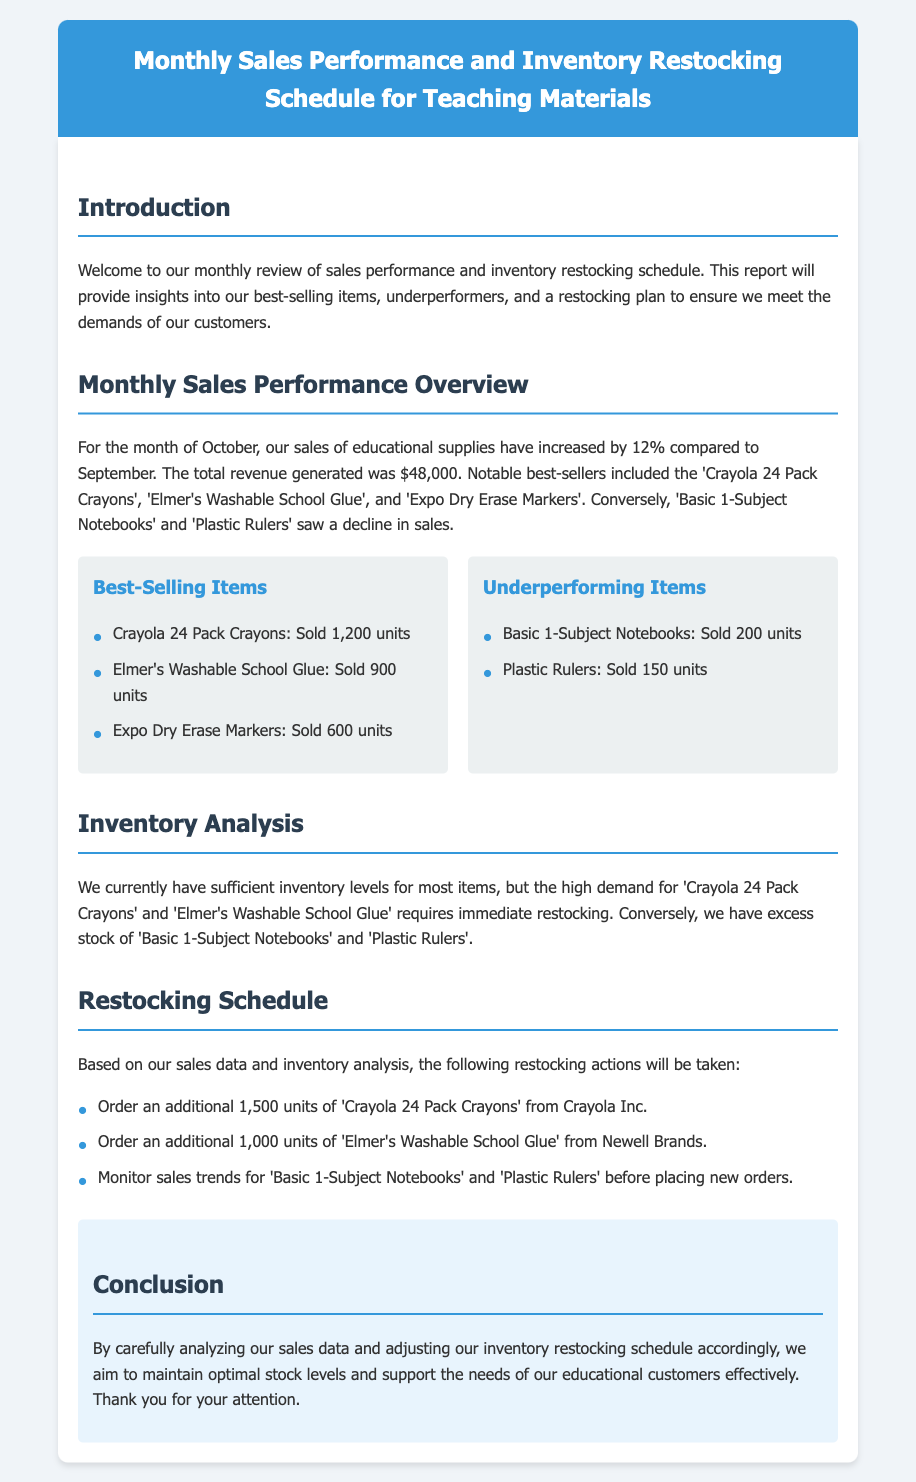What was the percentage increase in sales for October? The document states that sales increased by 12% compared to September.
Answer: 12% What is the total revenue generated in October? The document mentions the total revenue generated for the month of October was $48,000.
Answer: $48,000 How many units of 'Crayola 24 Pack Crayons' were sold? The document lists 1,200 units sold for 'Crayola 24 Pack Crayons'.
Answer: 1,200 units Which item saw a decline in sales? The document states that 'Basic 1-Subject Notebooks' and 'Plastic Rulers' saw a decline in sales.
Answer: Basic 1-Subject Notebooks What are the restocking quantities for 'Elmer's Washable School Glue'? The restocking action states to order an additional 1,000 units of 'Elmer's Washable School Glue'.
Answer: 1,000 units What is the conclusion's focus regarding stock levels? The conclusion emphasizes maintaining optimal stock levels based on sales data and inventory analysis.
Answer: Optimal stock levels What should be monitored before placing new orders for 'Basic 1-Subject Notebooks'? The document indicates to monitor sales trends for 'Basic 1-Subject Notebooks' before placing new orders.
Answer: Sales trends How many units of 'Expo Dry Erase Markers' were sold? The document specifies that 600 units of 'Expo Dry Erase Markers' were sold.
Answer: 600 units 